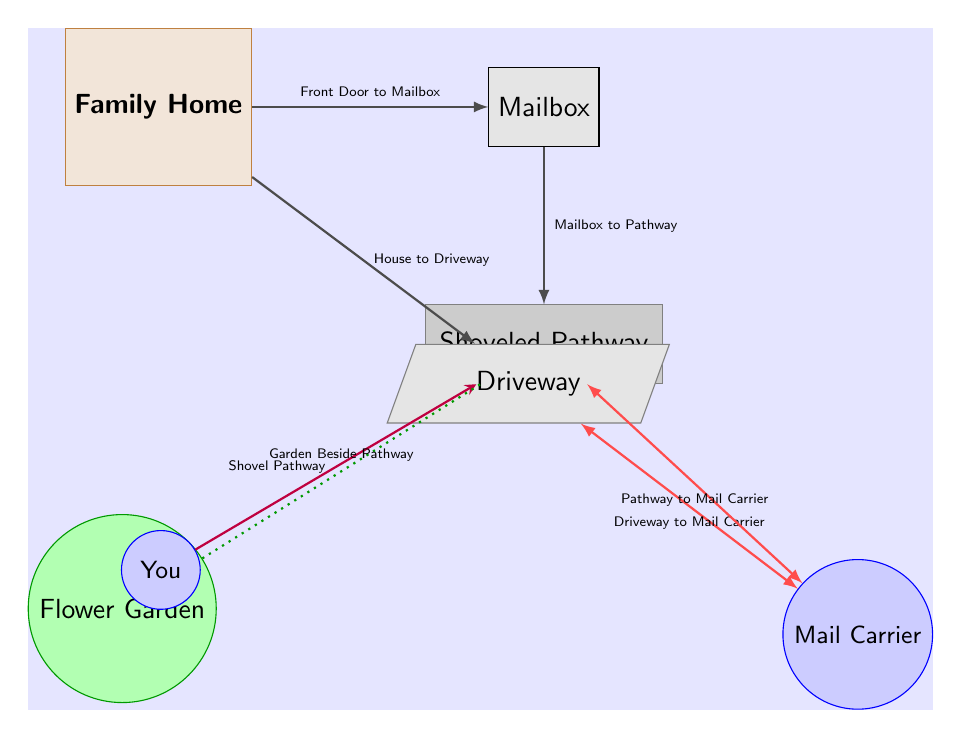What is located to the right of the family home? The diagram shows that the mailbox is positioned directly to the right of the family home. This relationship is denoted by a connecting arrow between the home and the mailbox.
Answer: Mailbox What is the path labeled as? According to the diagram, the path that leads to the mailbox is referred to as the "Shoveled Pathway." This label is visible next to the box labeled for the path.
Answer: Shoveled Pathway How many people are represented in the diagram? The diagram features two individuals: you and the mail carrier. Each person has a distinct labeled node.
Answer: 2 What kind of garden is adjacent to the pathway? The diagram indicates that there is a "Flower Garden" situated beside the pathway. This is explicitly labeled next to the corresponding garden node.
Answer: Flower Garden Which component connects the mailbox to the pathway? A connection line labeled "Mailbox to Pathway" illustrates the direct relationship between the mailbox and the path leading from it. This labeling helps identify the function of that connection.
Answer: Mailbox to Pathway What action is represented by the arrow coming from you? The diagram shows an arrow pointing from the node labeled "You" towards the "Shoveled Pathway," which signifies the action of shoveling the pathway. This indicates the action you perform in relation to the pathway.
Answer: Shovel Pathway How does the mail carrier get to the pathway? The diagram specifies that there is an interaction line labeled "Pathway to Mail Carrier" which indicates that the mail carrier uses the pathway to reach the mailbox area. Thus, the route for the mail carrier is defined through this connection.
Answer: Pathway to Mail Carrier What is the label associated with the area below the family home? The diagram shows that the area situated below the family home is labeled "Driveway." This information is given explicitly through the corresponding label in the diagram.
Answer: Driveway What do the dotted lines indicate in the diagram? The dotted line labeled "Garden Beside Pathway" signifies a proximity relationship, highlighting how the garden is positioned right next to the path. This visual cue is utilized to denote the spatial relationship between two elements.
Answer: Garden Beside Pathway 